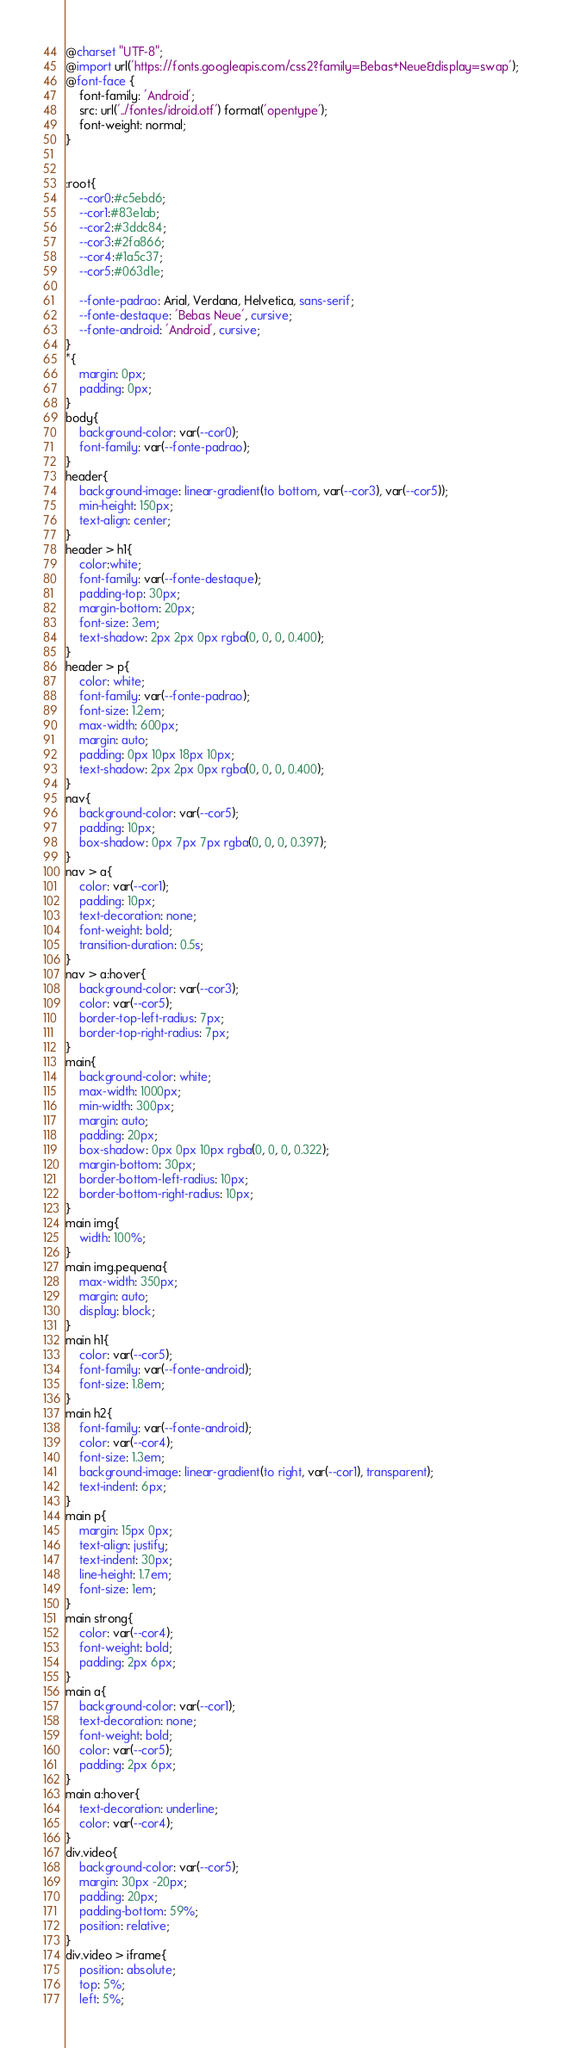Convert code to text. <code><loc_0><loc_0><loc_500><loc_500><_CSS_>@charset "UTF-8";
@import url('https://fonts.googleapis.com/css2?family=Bebas+Neue&display=swap');
@font-face {
    font-family: 'Android';
    src: url('../fontes/idroid.otf') format('opentype');
    font-weight: normal;
}


:root{
    --cor0:#c5ebd6;
    --cor1:#83e1ab;
    --cor2:#3ddc84;
    --cor3:#2fa866;
    --cor4:#1a5c37;
    --cor5:#063d1e;

    --fonte-padrao: Arial, Verdana, Helvetica, sans-serif;
    --fonte-destaque: 'Bebas Neue', cursive;
    --fonte-android: 'Android', cursive;
}
*{
    margin: 0px;
    padding: 0px;
}
body{
    background-color: var(--cor0);
    font-family: var(--fonte-padrao);
}
header{
    background-image: linear-gradient(to bottom, var(--cor3), var(--cor5));
    min-height: 150px;
    text-align: center;
}
header > h1{
    color:white;
    font-family: var(--fonte-destaque);
    padding-top: 30px;
    margin-bottom: 20px;
    font-size: 3em;
    text-shadow: 2px 2px 0px rgba(0, 0, 0, 0.400);
}
header > p{
    color: white;
    font-family: var(--fonte-padrao);
    font-size: 1.2em;
    max-width: 600px;
    margin: auto;
    padding: 0px 10px 18px 10px;
    text-shadow: 2px 2px 0px rgba(0, 0, 0, 0.400);
}
nav{
    background-color: var(--cor5);
    padding: 10px;
    box-shadow: 0px 7px 7px rgba(0, 0, 0, 0.397);
}
nav > a{
    color: var(--cor1);
    padding: 10px;
    text-decoration: none;
    font-weight: bold;
    transition-duration: 0.5s;
}
nav > a:hover{
    background-color: var(--cor3);
    color: var(--cor5);
    border-top-left-radius: 7px;
    border-top-right-radius: 7px;
}
main{
    background-color: white;
    max-width: 1000px;
    min-width: 300px;
    margin: auto;
    padding: 20px;
    box-shadow: 0px 0px 10px rgba(0, 0, 0, 0.322);
    margin-bottom: 30px;
    border-bottom-left-radius: 10px;
    border-bottom-right-radius: 10px;
}
main img{
    width: 100%;
}
main img.pequena{
    max-width: 350px;
    margin: auto;
    display: block;
}
main h1{
    color: var(--cor5);
    font-family: var(--fonte-android);
    font-size: 1.8em;
}
main h2{
    font-family: var(--fonte-android);
    color: var(--cor4);
    font-size: 1.3em;
    background-image: linear-gradient(to right, var(--cor1), transparent);
    text-indent: 6px;
}
main p{
    margin: 15px 0px;
    text-align: justify;
    text-indent: 30px;
    line-height: 1.7em;
    font-size: 1em;
}
main strong{
    color: var(--cor4);
    font-weight: bold;
    padding: 2px 6px;
}
main a{
    background-color: var(--cor1);
    text-decoration: none;
    font-weight: bold;
    color: var(--cor5);
    padding: 2px 6px;
}
main a:hover{
    text-decoration: underline;
    color: var(--cor4);
}
div.video{
    background-color: var(--cor5);
    margin: 30px -20px;
    padding: 20px;
    padding-bottom: 59%;
    position: relative;
}
div.video > iframe{
    position: absolute;
    top: 5%;
    left: 5%;</code> 